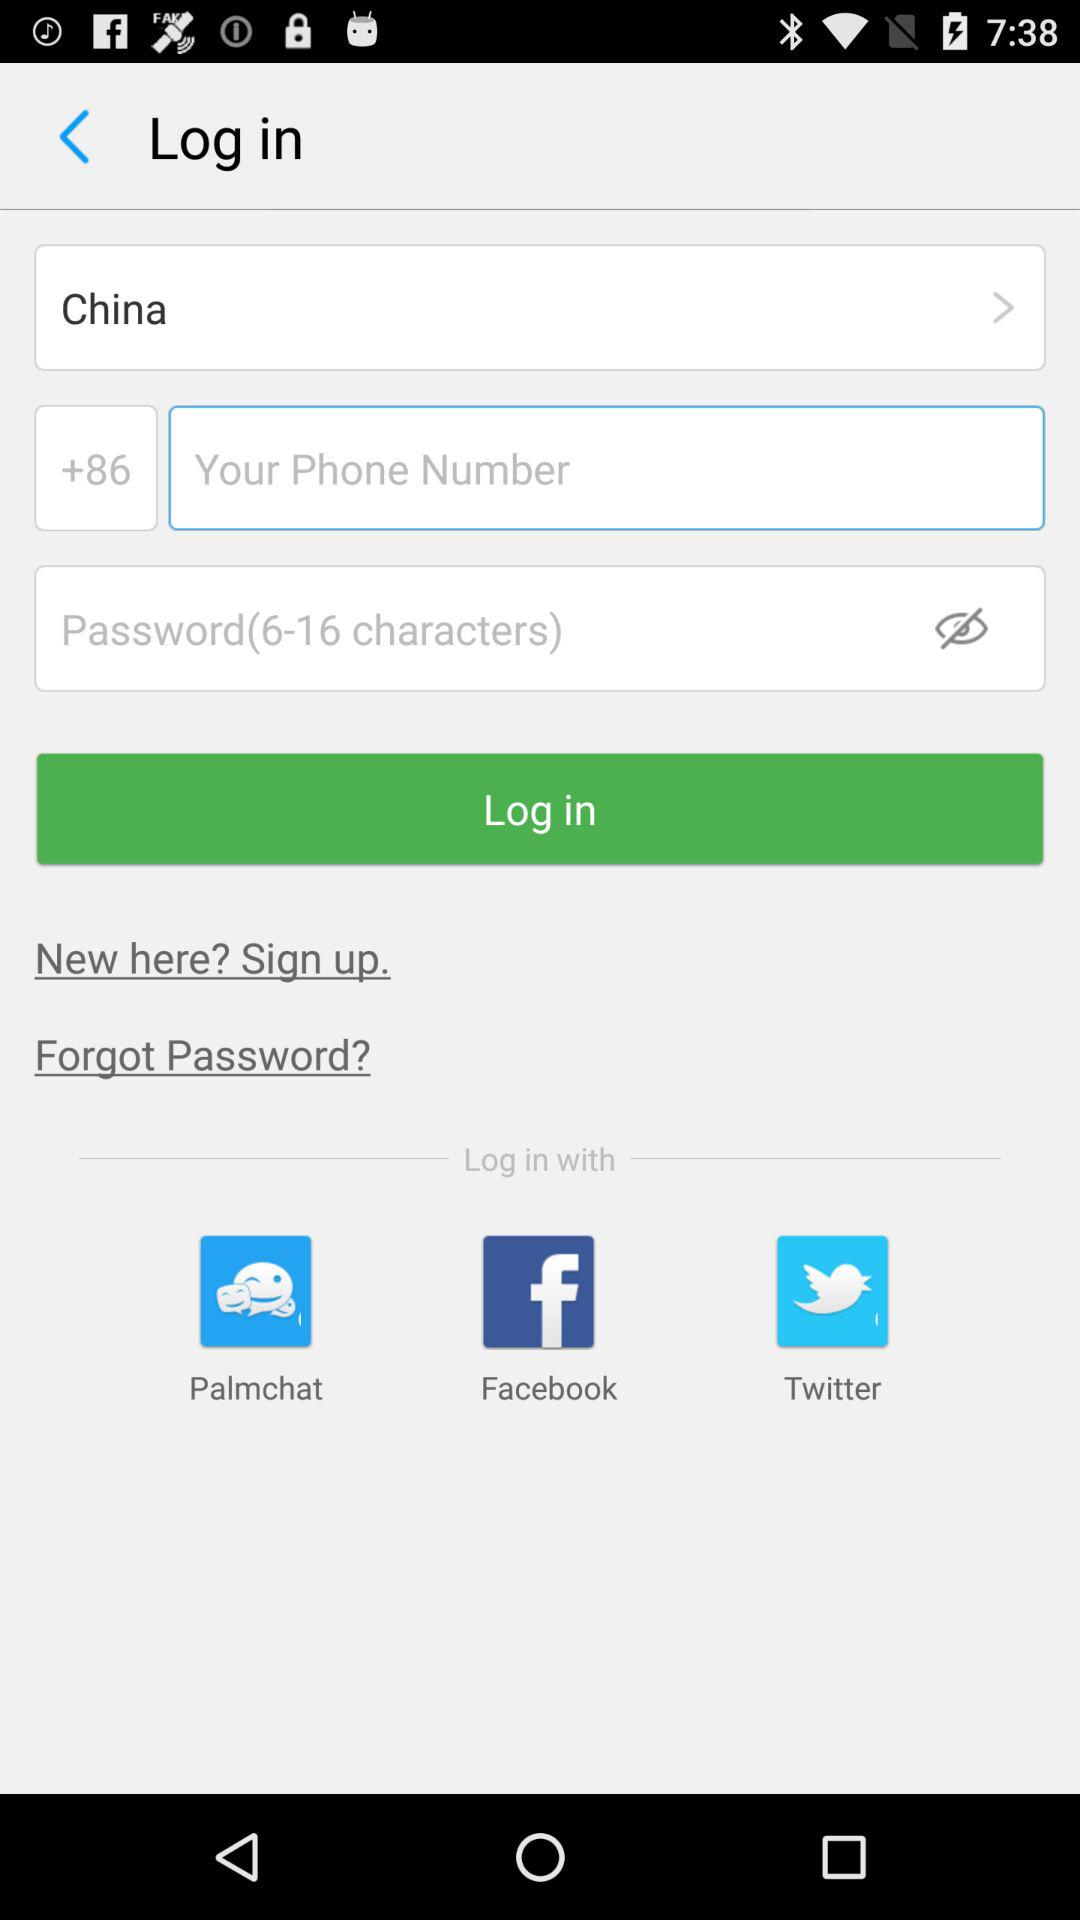What is the country code mentioned?
Answer the question using a single word or phrase. The country code is +86 